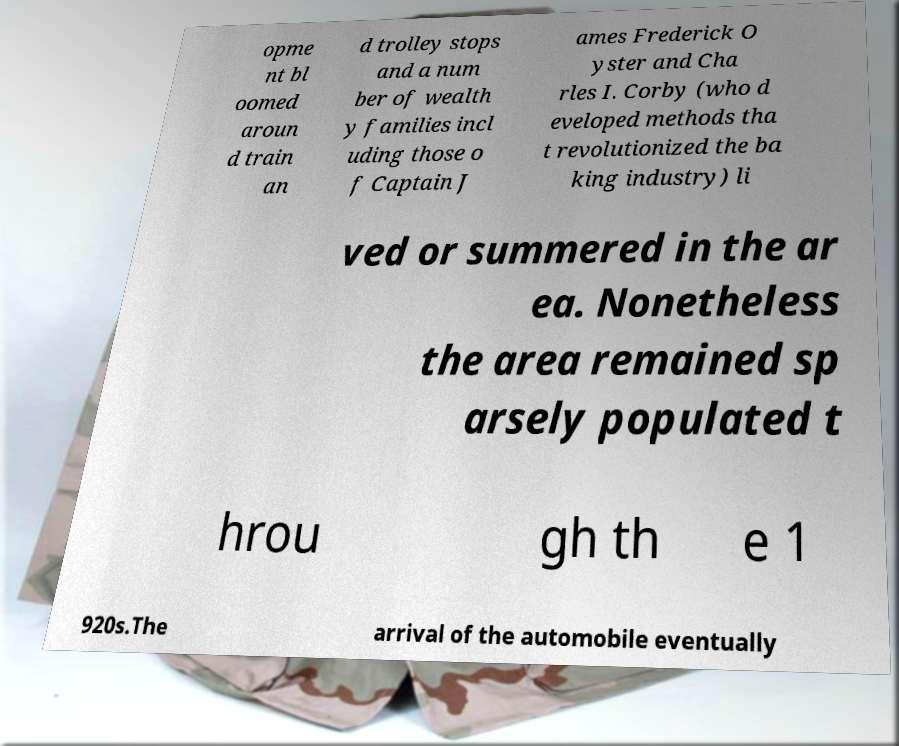What messages or text are displayed in this image? I need them in a readable, typed format. opme nt bl oomed aroun d train an d trolley stops and a num ber of wealth y families incl uding those o f Captain J ames Frederick O yster and Cha rles I. Corby (who d eveloped methods tha t revolutionized the ba king industry) li ved or summered in the ar ea. Nonetheless the area remained sp arsely populated t hrou gh th e 1 920s.The arrival of the automobile eventually 